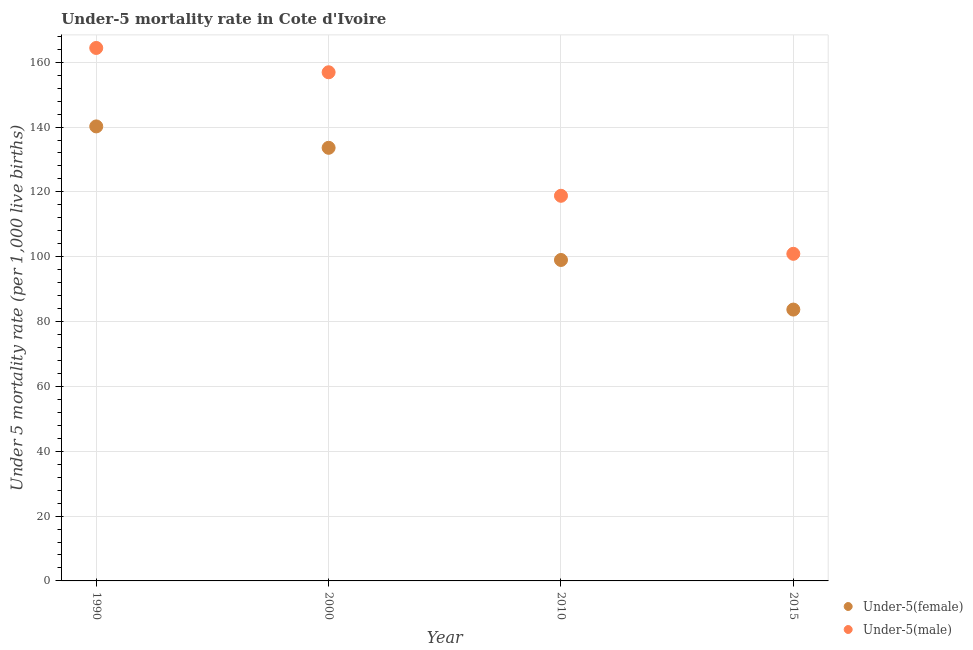How many different coloured dotlines are there?
Provide a succinct answer. 2. Is the number of dotlines equal to the number of legend labels?
Keep it short and to the point. Yes. What is the under-5 female mortality rate in 2000?
Keep it short and to the point. 133.6. Across all years, what is the maximum under-5 female mortality rate?
Offer a very short reply. 140.2. Across all years, what is the minimum under-5 female mortality rate?
Provide a succinct answer. 83.7. In which year was the under-5 male mortality rate maximum?
Your response must be concise. 1990. In which year was the under-5 female mortality rate minimum?
Your response must be concise. 2015. What is the total under-5 male mortality rate in the graph?
Provide a short and direct response. 541. What is the difference between the under-5 female mortality rate in 2010 and that in 2015?
Your response must be concise. 15.3. What is the difference between the under-5 male mortality rate in 2010 and the under-5 female mortality rate in 2015?
Offer a very short reply. 35.1. What is the average under-5 male mortality rate per year?
Provide a short and direct response. 135.25. In the year 1990, what is the difference between the under-5 female mortality rate and under-5 male mortality rate?
Ensure brevity in your answer.  -24.2. In how many years, is the under-5 female mortality rate greater than 8?
Offer a very short reply. 4. What is the ratio of the under-5 female mortality rate in 1990 to that in 2010?
Keep it short and to the point. 1.42. What is the difference between the highest and the second highest under-5 female mortality rate?
Offer a terse response. 6.6. What is the difference between the highest and the lowest under-5 female mortality rate?
Your answer should be very brief. 56.5. In how many years, is the under-5 female mortality rate greater than the average under-5 female mortality rate taken over all years?
Offer a terse response. 2. Is the under-5 female mortality rate strictly less than the under-5 male mortality rate over the years?
Provide a succinct answer. Yes. What is the difference between two consecutive major ticks on the Y-axis?
Offer a terse response. 20. Are the values on the major ticks of Y-axis written in scientific E-notation?
Provide a short and direct response. No. Where does the legend appear in the graph?
Your answer should be compact. Bottom right. How are the legend labels stacked?
Keep it short and to the point. Vertical. What is the title of the graph?
Provide a succinct answer. Under-5 mortality rate in Cote d'Ivoire. What is the label or title of the Y-axis?
Provide a short and direct response. Under 5 mortality rate (per 1,0 live births). What is the Under 5 mortality rate (per 1,000 live births) of Under-5(female) in 1990?
Provide a short and direct response. 140.2. What is the Under 5 mortality rate (per 1,000 live births) in Under-5(male) in 1990?
Offer a very short reply. 164.4. What is the Under 5 mortality rate (per 1,000 live births) in Under-5(female) in 2000?
Ensure brevity in your answer.  133.6. What is the Under 5 mortality rate (per 1,000 live births) in Under-5(male) in 2000?
Make the answer very short. 156.9. What is the Under 5 mortality rate (per 1,000 live births) in Under-5(male) in 2010?
Offer a terse response. 118.8. What is the Under 5 mortality rate (per 1,000 live births) in Under-5(female) in 2015?
Your answer should be very brief. 83.7. What is the Under 5 mortality rate (per 1,000 live births) of Under-5(male) in 2015?
Keep it short and to the point. 100.9. Across all years, what is the maximum Under 5 mortality rate (per 1,000 live births) of Under-5(female)?
Your answer should be compact. 140.2. Across all years, what is the maximum Under 5 mortality rate (per 1,000 live births) of Under-5(male)?
Your answer should be compact. 164.4. Across all years, what is the minimum Under 5 mortality rate (per 1,000 live births) of Under-5(female)?
Your response must be concise. 83.7. Across all years, what is the minimum Under 5 mortality rate (per 1,000 live births) of Under-5(male)?
Offer a very short reply. 100.9. What is the total Under 5 mortality rate (per 1,000 live births) in Under-5(female) in the graph?
Keep it short and to the point. 456.5. What is the total Under 5 mortality rate (per 1,000 live births) of Under-5(male) in the graph?
Give a very brief answer. 541. What is the difference between the Under 5 mortality rate (per 1,000 live births) in Under-5(female) in 1990 and that in 2010?
Keep it short and to the point. 41.2. What is the difference between the Under 5 mortality rate (per 1,000 live births) in Under-5(male) in 1990 and that in 2010?
Give a very brief answer. 45.6. What is the difference between the Under 5 mortality rate (per 1,000 live births) in Under-5(female) in 1990 and that in 2015?
Make the answer very short. 56.5. What is the difference between the Under 5 mortality rate (per 1,000 live births) in Under-5(male) in 1990 and that in 2015?
Offer a terse response. 63.5. What is the difference between the Under 5 mortality rate (per 1,000 live births) in Under-5(female) in 2000 and that in 2010?
Provide a short and direct response. 34.6. What is the difference between the Under 5 mortality rate (per 1,000 live births) of Under-5(male) in 2000 and that in 2010?
Ensure brevity in your answer.  38.1. What is the difference between the Under 5 mortality rate (per 1,000 live births) in Under-5(female) in 2000 and that in 2015?
Offer a terse response. 49.9. What is the difference between the Under 5 mortality rate (per 1,000 live births) in Under-5(female) in 2010 and that in 2015?
Offer a terse response. 15.3. What is the difference between the Under 5 mortality rate (per 1,000 live births) of Under-5(female) in 1990 and the Under 5 mortality rate (per 1,000 live births) of Under-5(male) in 2000?
Your answer should be compact. -16.7. What is the difference between the Under 5 mortality rate (per 1,000 live births) in Under-5(female) in 1990 and the Under 5 mortality rate (per 1,000 live births) in Under-5(male) in 2010?
Ensure brevity in your answer.  21.4. What is the difference between the Under 5 mortality rate (per 1,000 live births) in Under-5(female) in 1990 and the Under 5 mortality rate (per 1,000 live births) in Under-5(male) in 2015?
Offer a very short reply. 39.3. What is the difference between the Under 5 mortality rate (per 1,000 live births) of Under-5(female) in 2000 and the Under 5 mortality rate (per 1,000 live births) of Under-5(male) in 2010?
Ensure brevity in your answer.  14.8. What is the difference between the Under 5 mortality rate (per 1,000 live births) in Under-5(female) in 2000 and the Under 5 mortality rate (per 1,000 live births) in Under-5(male) in 2015?
Keep it short and to the point. 32.7. What is the difference between the Under 5 mortality rate (per 1,000 live births) of Under-5(female) in 2010 and the Under 5 mortality rate (per 1,000 live births) of Under-5(male) in 2015?
Ensure brevity in your answer.  -1.9. What is the average Under 5 mortality rate (per 1,000 live births) in Under-5(female) per year?
Give a very brief answer. 114.12. What is the average Under 5 mortality rate (per 1,000 live births) in Under-5(male) per year?
Provide a short and direct response. 135.25. In the year 1990, what is the difference between the Under 5 mortality rate (per 1,000 live births) in Under-5(female) and Under 5 mortality rate (per 1,000 live births) in Under-5(male)?
Ensure brevity in your answer.  -24.2. In the year 2000, what is the difference between the Under 5 mortality rate (per 1,000 live births) of Under-5(female) and Under 5 mortality rate (per 1,000 live births) of Under-5(male)?
Provide a succinct answer. -23.3. In the year 2010, what is the difference between the Under 5 mortality rate (per 1,000 live births) of Under-5(female) and Under 5 mortality rate (per 1,000 live births) of Under-5(male)?
Offer a terse response. -19.8. In the year 2015, what is the difference between the Under 5 mortality rate (per 1,000 live births) in Under-5(female) and Under 5 mortality rate (per 1,000 live births) in Under-5(male)?
Offer a very short reply. -17.2. What is the ratio of the Under 5 mortality rate (per 1,000 live births) in Under-5(female) in 1990 to that in 2000?
Offer a very short reply. 1.05. What is the ratio of the Under 5 mortality rate (per 1,000 live births) in Under-5(male) in 1990 to that in 2000?
Keep it short and to the point. 1.05. What is the ratio of the Under 5 mortality rate (per 1,000 live births) in Under-5(female) in 1990 to that in 2010?
Keep it short and to the point. 1.42. What is the ratio of the Under 5 mortality rate (per 1,000 live births) in Under-5(male) in 1990 to that in 2010?
Keep it short and to the point. 1.38. What is the ratio of the Under 5 mortality rate (per 1,000 live births) of Under-5(female) in 1990 to that in 2015?
Make the answer very short. 1.68. What is the ratio of the Under 5 mortality rate (per 1,000 live births) of Under-5(male) in 1990 to that in 2015?
Your answer should be very brief. 1.63. What is the ratio of the Under 5 mortality rate (per 1,000 live births) in Under-5(female) in 2000 to that in 2010?
Your response must be concise. 1.35. What is the ratio of the Under 5 mortality rate (per 1,000 live births) in Under-5(male) in 2000 to that in 2010?
Your response must be concise. 1.32. What is the ratio of the Under 5 mortality rate (per 1,000 live births) in Under-5(female) in 2000 to that in 2015?
Your answer should be very brief. 1.6. What is the ratio of the Under 5 mortality rate (per 1,000 live births) of Under-5(male) in 2000 to that in 2015?
Ensure brevity in your answer.  1.55. What is the ratio of the Under 5 mortality rate (per 1,000 live births) in Under-5(female) in 2010 to that in 2015?
Provide a succinct answer. 1.18. What is the ratio of the Under 5 mortality rate (per 1,000 live births) of Under-5(male) in 2010 to that in 2015?
Offer a very short reply. 1.18. What is the difference between the highest and the second highest Under 5 mortality rate (per 1,000 live births) in Under-5(female)?
Give a very brief answer. 6.6. What is the difference between the highest and the lowest Under 5 mortality rate (per 1,000 live births) of Under-5(female)?
Make the answer very short. 56.5. What is the difference between the highest and the lowest Under 5 mortality rate (per 1,000 live births) of Under-5(male)?
Offer a terse response. 63.5. 